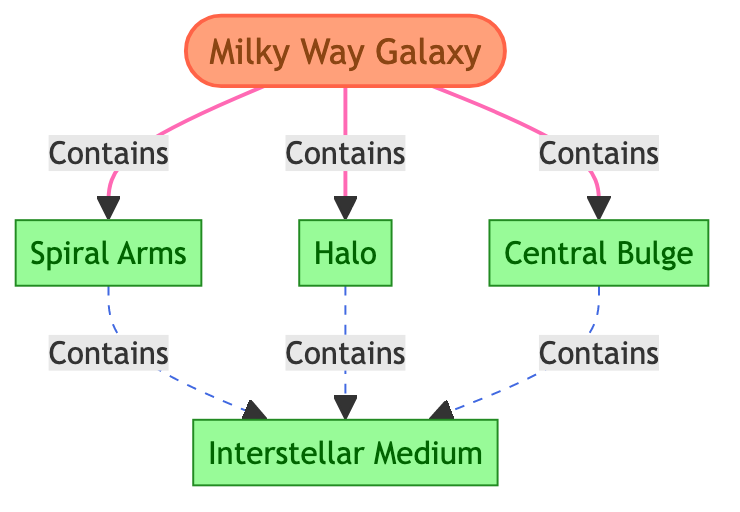What are the components of the Milky Way Galaxy? The diagram indicates that the Milky Way Galaxy contains three main components: Spiral Arms, Halo, and Central Bulge.
Answer: Spiral Arms, Halo, Central Bulge How many nodes are present in the diagram? There are a total of five nodes: Milky Way Galaxy, Spiral Arms, Halo, Central Bulge, and Interstellar Medium.
Answer: 5 Which component is linked to the Interstellar Medium? The diagram shows that the Interstellar Medium is contained within the Spiral Arms, Halo, and the Central Bulge.
Answer: Spiral Arms, Halo, Central Bulge What links the Spiral Arms to the Milky Way Galaxy? The connection is indicated by the 'Contains' relationship directed from the Milky Way Galaxy node to the Spiral Arms node.
Answer: Contains What type of link connects the Halo and Central Bulge to the Interstellar Medium? The diagram uses a dashed link style to show that both Halo and Central Bulge contain the Interstellar Medium.
Answer: Dashed link How many components are directly linked to the Milky Way Galaxy? The Milky Way Galaxy has three components directly linked to it: Spiral Arms, Halo, and Central Bulge.
Answer: 3 Which node has the most direct connections? The Interstellar Medium node connects to three components: Spiral Arms, Halo, and Central Bulge, making it the node with the most connections.
Answer: Interstellar Medium What does the Central Bulge contain? According to the diagram, the Central Bulge contains the Interstellar Medium.
Answer: Interstellar Medium How are the nodes categorized in the diagram? The diagram classifies nodes into two categories: the central node (Milky Way Galaxy) and sub-components (Spiral Arms, Halo, Central Bulge, Interstellar Medium).
Answer: Central node, sub-components 